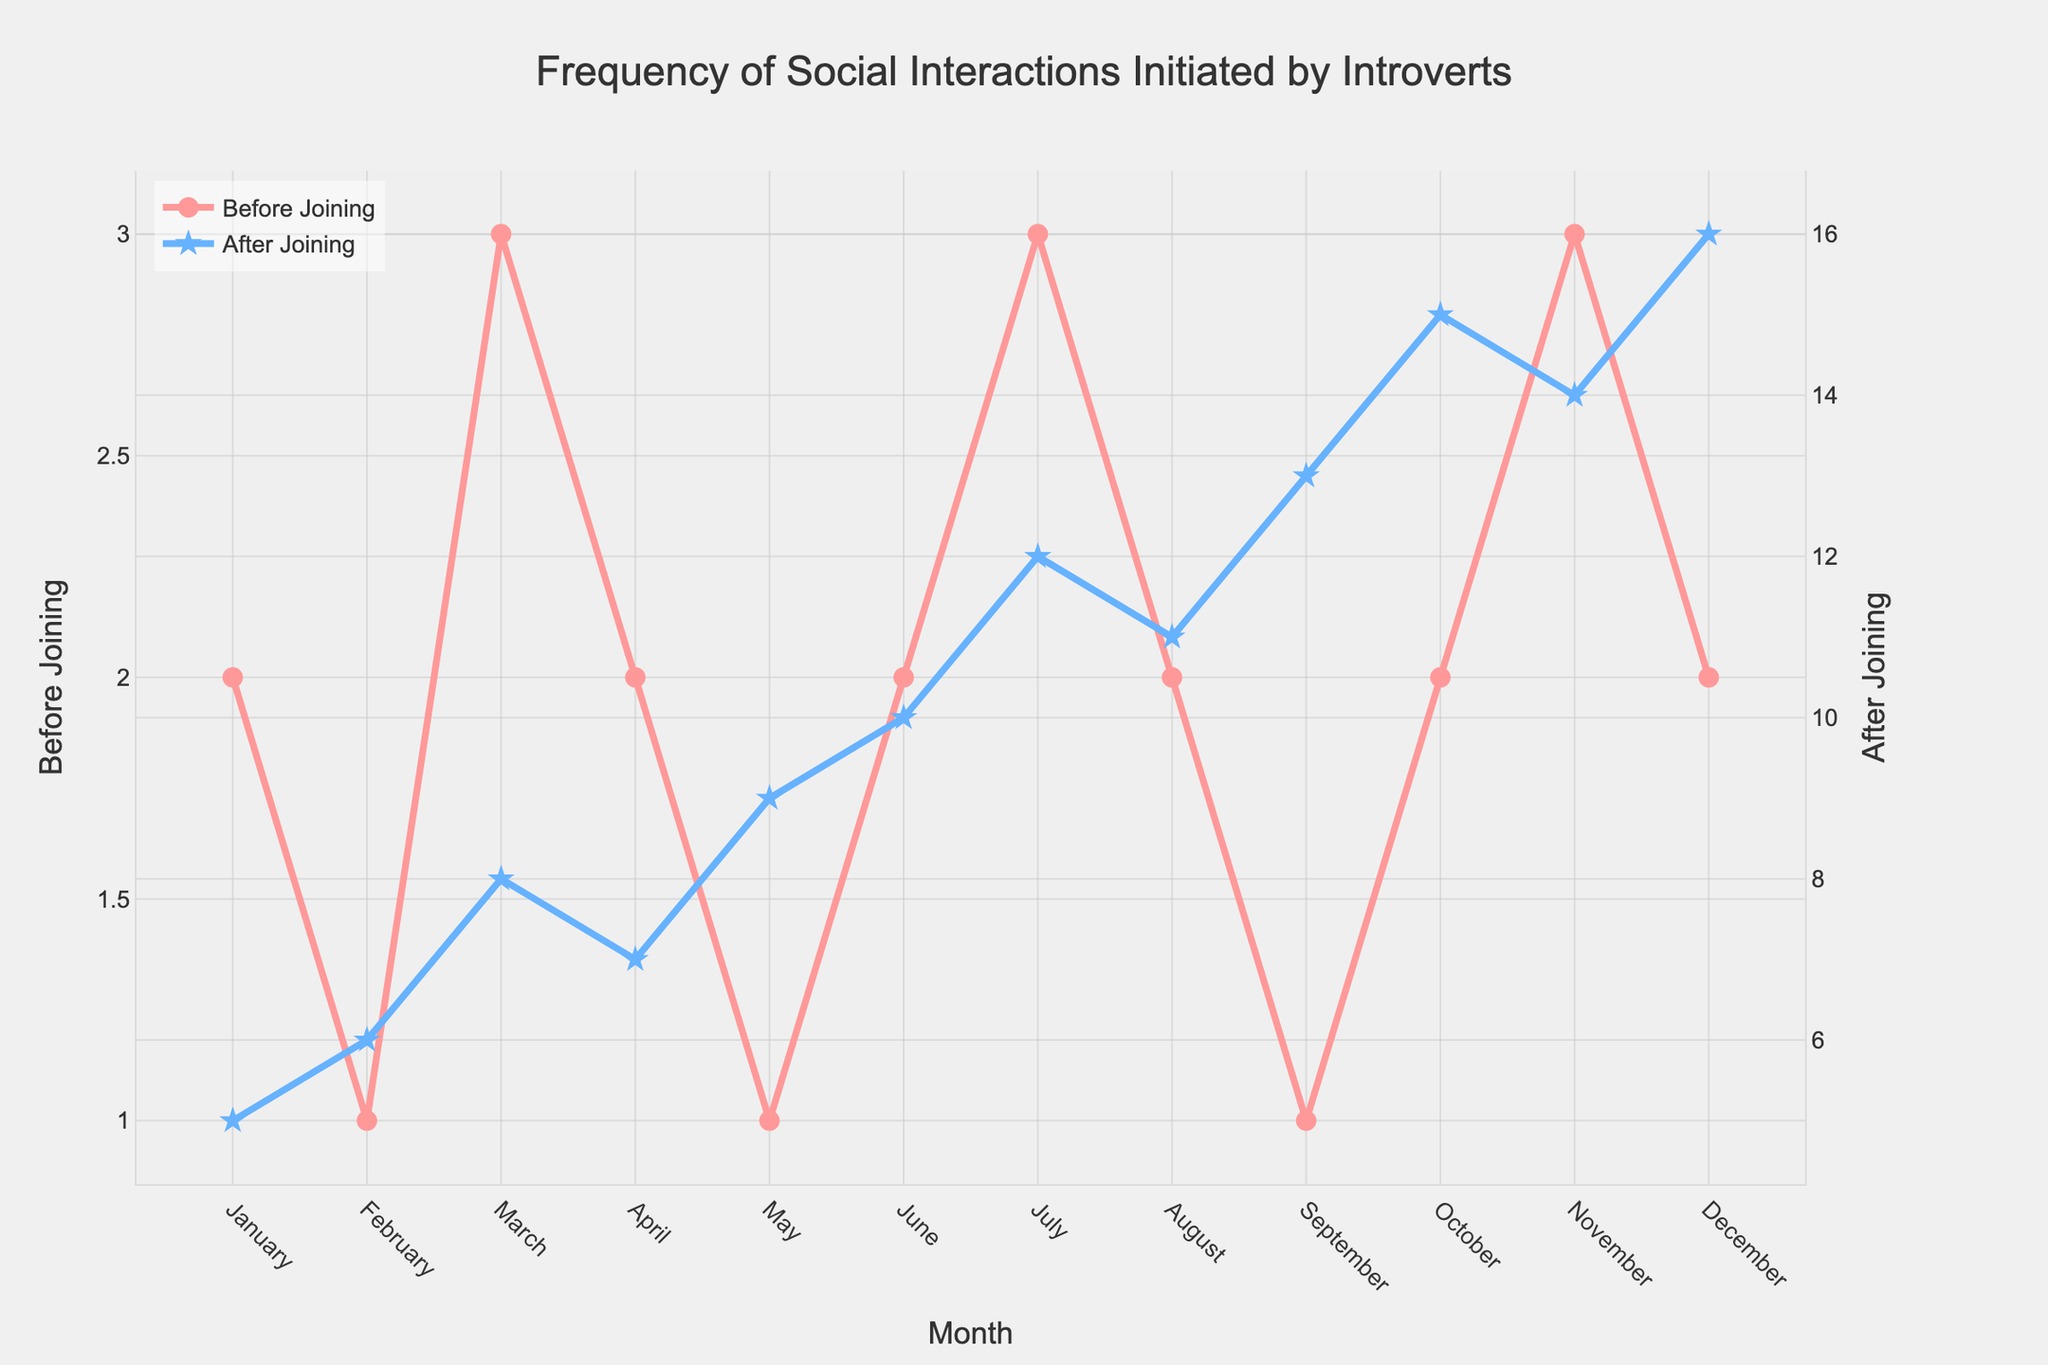What is the highest frequency of social interactions initiated by introverts before joining hobby groups? Look at the "Before Joining" line and find the highest value on the y-axis. The highest point in the "Before Joining" line is 3 which occurs in March, July, and November.
Answer: 3 What is the highest frequency of social interactions initiated by introverts after joining hobby groups? Look at the "After Joining" line and find the highest value on the y-axis. The highest point in the "After Joining" line is 16 which occurs in December.
Answer: 16 In which month do the social interactions of introverts increase the most after joining hobby groups? Compare the differences between "Before Joining" and "After Joining" for each month and look for the largest increase. The largest increase is from January (difference of 3).
Answer: December Which month shows the least difference in social interactions before and after joining hobby groups? Calculate the difference between "Before Joining" and "After Joining" for each month and find the smallest difference. The smallest difference is in August with 9 - 2 = 7.
Answer: August What is the average frequency of social interactions initiated by introverts before joining hobby groups over the year? Sum the frequencies from "Before Joining" and divide by the number of months (12): (2+1+3+2+1+2+3+2+1+2+3+2)/12 = 2.
Answer: 2 What is the average frequency of social interactions initiated by introverts after joining hobby groups over the year? Sum the frequencies from "After Joining" and divide by the number of months (12): (5+6+8+7+9+10+12+11+13+15+14+16) / 12 = 10.75.
Answer: 10.75 How much did the frequency of social interactions initiated by introverts increase from January to December after joining hobby groups? Look at the "After Joining" line and subtract the value in January from December: 16 - 5 = 11.
Answer: 11 What color represents the frequency of social interactions initiated by introverts before joining hobby groups? Check the legend for "Before Joining". The line is red.
Answer: Red What color represents the frequency of social interactions initiated by introverts after joining hobby groups? Check the legend for "After Joining". The line is blue.
Answer: Blue Which months have the same frequency of social interactions before joining hobby groups? Look at the "Before Joining" line and identify months with the same y-axis values. February, May, September all have a frequency of 1 before joining, and January, April, June, August, October, December all have a frequency of 2.
Answer: February, May, September and January, April, June, August, October, December 